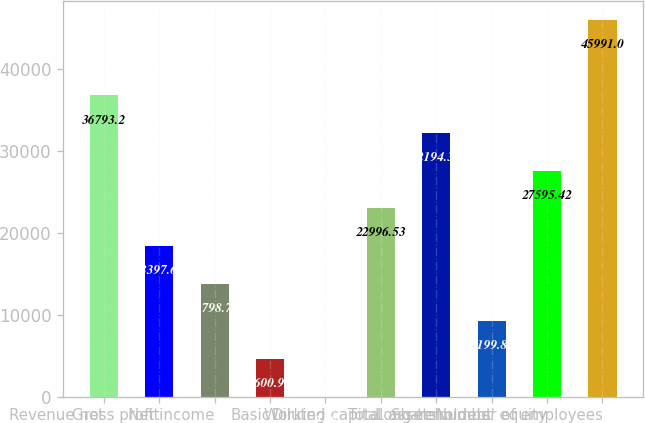Convert chart to OTSL. <chart><loc_0><loc_0><loc_500><loc_500><bar_chart><fcel>Revenue net<fcel>Gross profit<fcel>Net income<fcel>Basic<fcel>Diluted<fcel>Working capital<fcel>Total assets<fcel>Long-term debt<fcel>Shareholders' equity<fcel>Number of employees<nl><fcel>36793.2<fcel>18397.6<fcel>13798.8<fcel>4600.97<fcel>2.08<fcel>22996.5<fcel>32194.3<fcel>9199.86<fcel>27595.4<fcel>45991<nl></chart> 